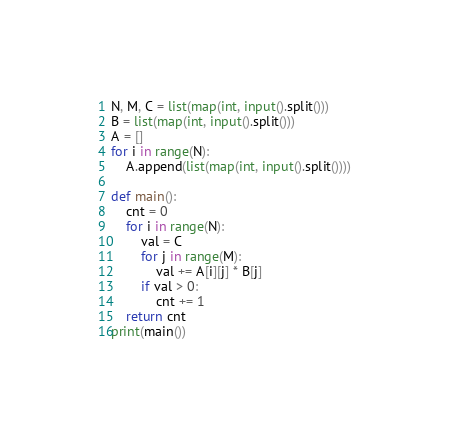Convert code to text. <code><loc_0><loc_0><loc_500><loc_500><_Python_>N, M, C = list(map(int, input().split()))
B = list(map(int, input().split()))
A = []
for i in range(N):
	A.append(list(map(int, input().split())))
	
def main():
	cnt = 0
	for i in range(N):
		val = C
		for j in range(M):
			val += A[i][j] * B[j]
		if val > 0:
			cnt += 1
	return cnt
print(main())
</code> 